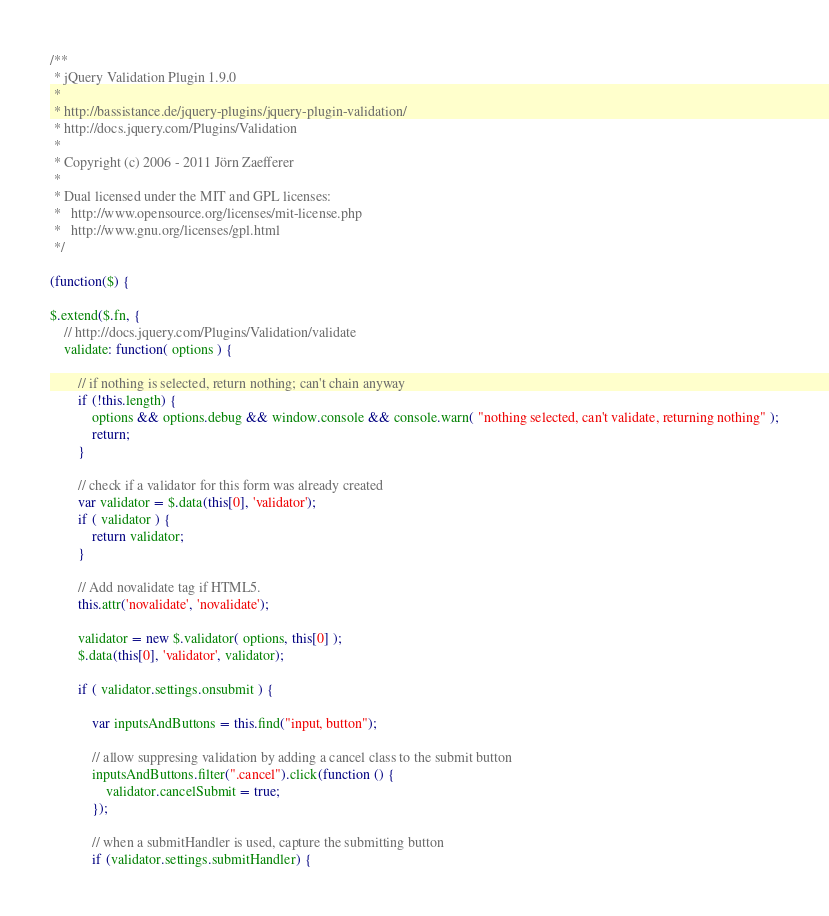Convert code to text. <code><loc_0><loc_0><loc_500><loc_500><_JavaScript_>/**
 * jQuery Validation Plugin 1.9.0
 *
 * http://bassistance.de/jquery-plugins/jquery-plugin-validation/
 * http://docs.jquery.com/Plugins/Validation
 *
 * Copyright (c) 2006 - 2011 Jörn Zaefferer
 *
 * Dual licensed under the MIT and GPL licenses:
 *   http://www.opensource.org/licenses/mit-license.php
 *   http://www.gnu.org/licenses/gpl.html
 */

(function($) {

$.extend($.fn, {
	// http://docs.jquery.com/Plugins/Validation/validate
	validate: function( options ) {

		// if nothing is selected, return nothing; can't chain anyway
		if (!this.length) {
			options && options.debug && window.console && console.warn( "nothing selected, can't validate, returning nothing" );
			return;
		}

		// check if a validator for this form was already created
		var validator = $.data(this[0], 'validator');
		if ( validator ) {
			return validator;
		}

		// Add novalidate tag if HTML5.
		this.attr('novalidate', 'novalidate');

		validator = new $.validator( options, this[0] );
		$.data(this[0], 'validator', validator);

		if ( validator.settings.onsubmit ) {

			var inputsAndButtons = this.find("input, button");

			// allow suppresing validation by adding a cancel class to the submit button
			inputsAndButtons.filter(".cancel").click(function () {
				validator.cancelSubmit = true;
			});

			// when a submitHandler is used, capture the submitting button
			if (validator.settings.submitHandler) {</code> 